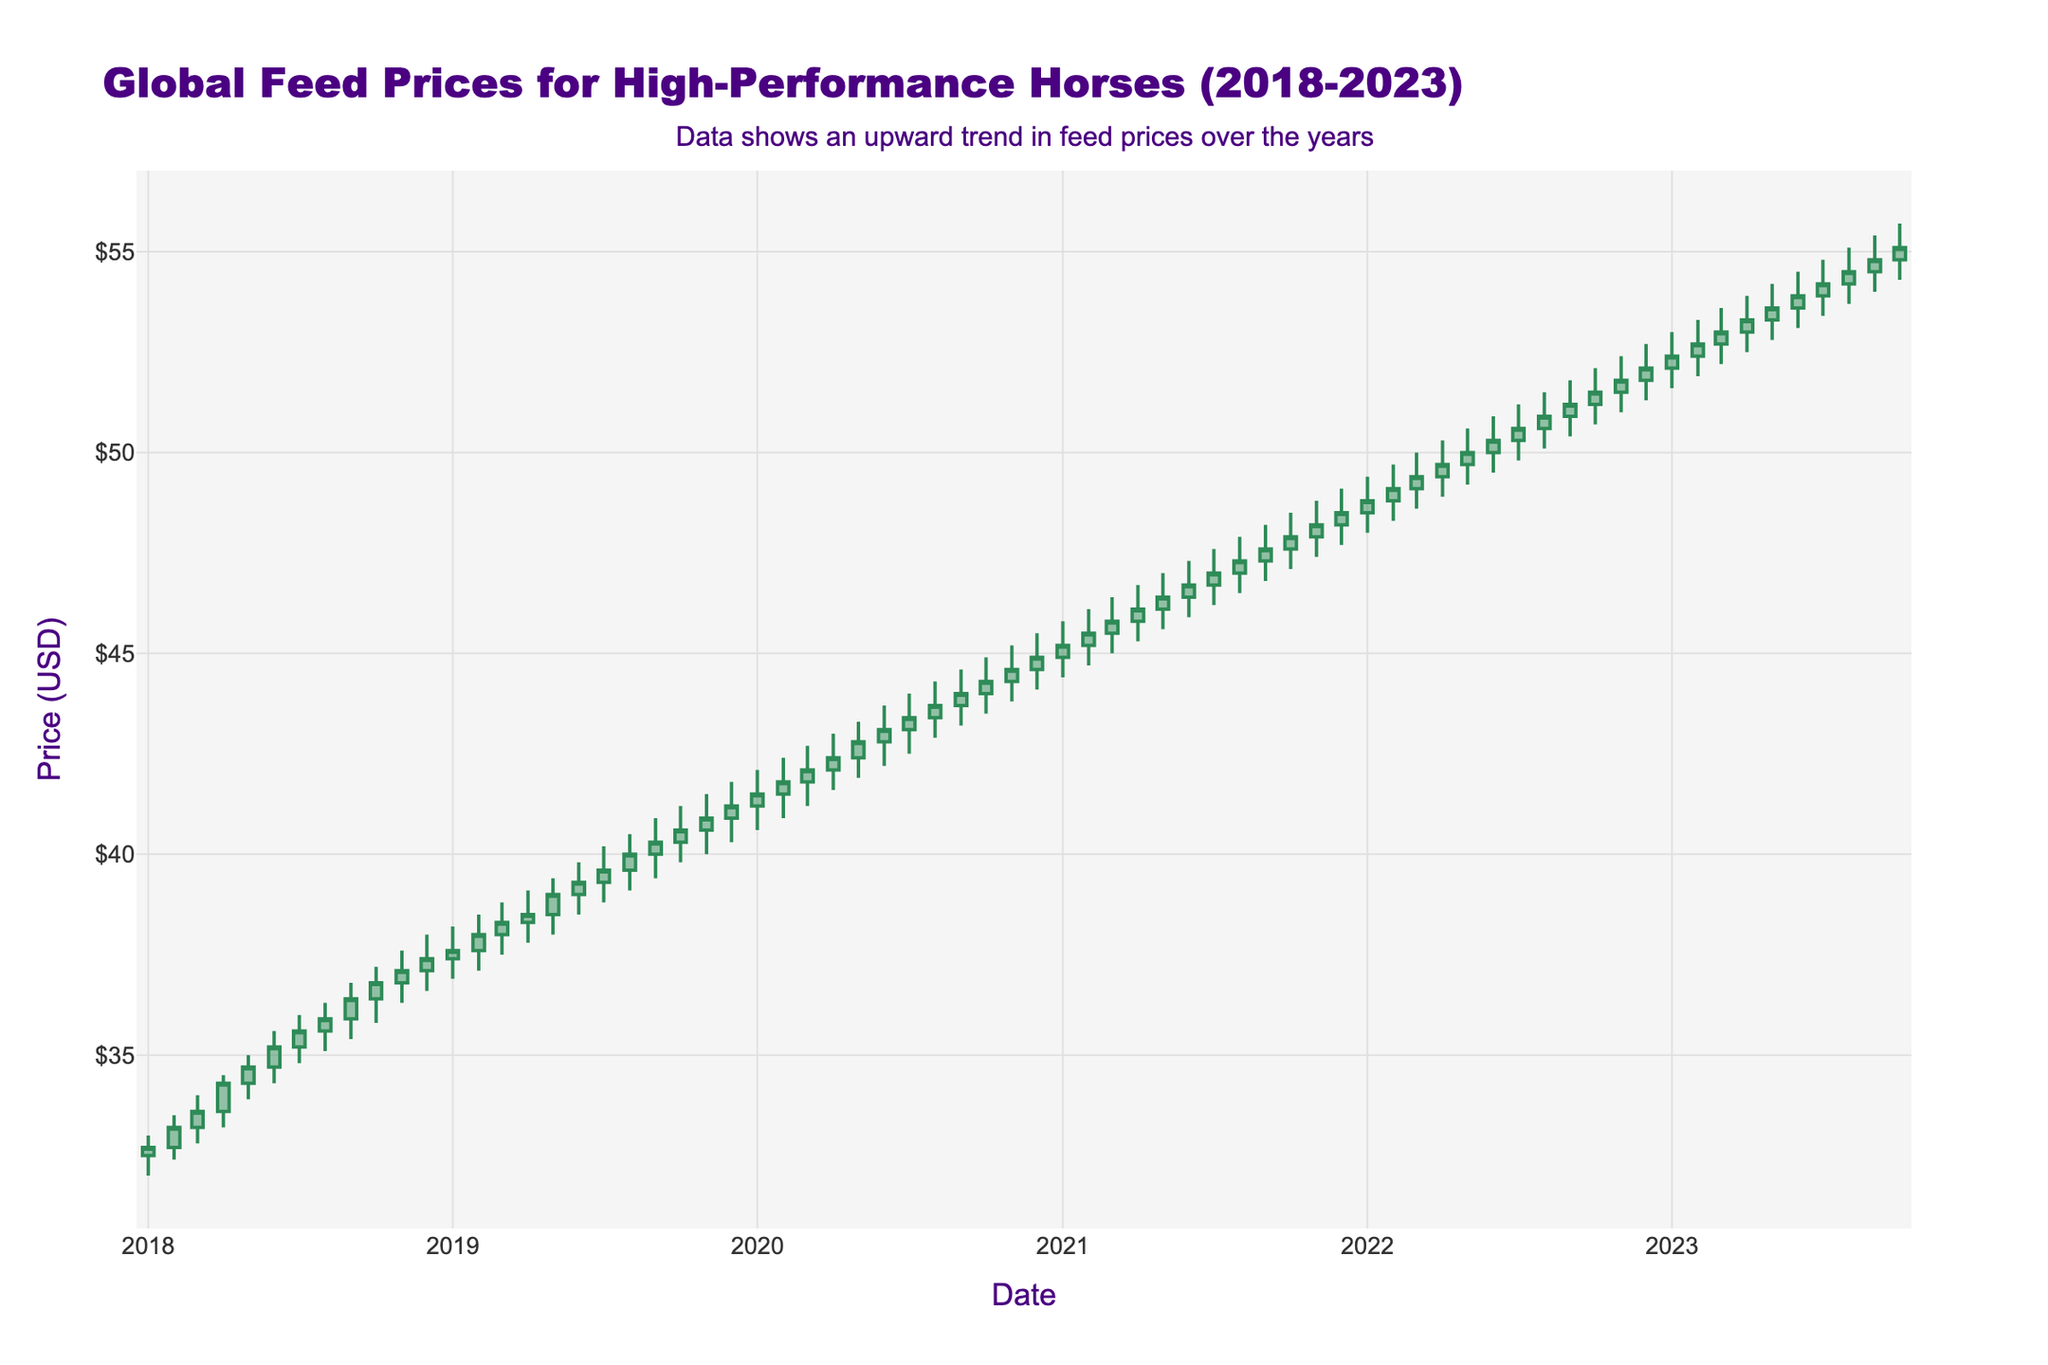What is the title of the figure? The title is located at the top of the figure and it reads "Global Feed Prices for High-Performance Horses (2018-2023)"
Answer: Global Feed Prices for High-Performance Horses (2018-2023) What is the general trend in global feed prices for high-performance horses from 2018 to 2023? To determine the trend, observe the overall movement of the candlesticks, which generally show an upward movement from the lower values in 2018 to the higher values in 2023
Answer: Upward What was the highest price recorded within the last five years? The highest price can be identified by looking for the tallest candlestick representing the highest peak, which occurs in the candlestick for October 2023
Answer: $55.7 In which month and year did the opening price first cross the $50 mark? Identify the candlestick where the opening price exceeds $50 by observing the open price annotations starting from around January 2022, which shows the open at $50.0
Answer: June 2022 What color indicates an increasing price, and what color indicates a decreasing price? Refer to the legend or color distinction in the chart to identify that increasing prices are represented by sea green color and decreasing prices by saddle brown color
Answer: Sea Green for increasing, Saddle Brown for decreasing Which month in 2021 had the highest closing price? Scan through the candlesticks for the year 2021 and identify which one has the highest closing price value annotated, which is December 2021 with a closing at $48.5
Answer: December 2021 Compare the opening prices of January 2020 and January 2023. Which is higher and by how much? Locate January 2020 ($41.2) and January 2023 ($52.1) on the x-axis, compare the two open values and subtract the earlier from the later
Answer: January 2023 is higher by $10.9 What was the price change between October 2020 and November 2020? For price change calculation, subtract the closing price of October 2020 ($44.3) from the closing price of November 2020 ($44.6)
Answer: $0.3 How many data points were plotted in total? Count the intervals from January 2018 to October 2023 by counting the bars or intervals plotted along the x-axis
Answer: 70 What can you infer about price volatility from the width of the candlesticks? Wider candlesticks with longer upper and lower shadows during certain months indicate high volatility, suggesting greater price fluctuations in those periods, for example, around late 2019
Answer: Higher price volatility in certain months around late 2019 